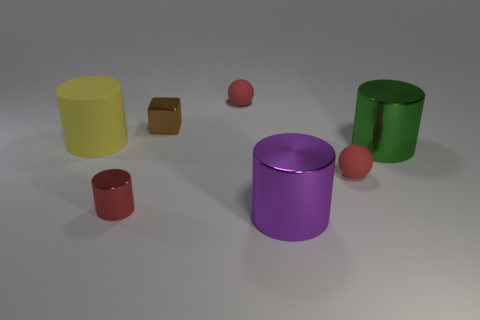Is the shape of the large metallic object that is behind the red shiny cylinder the same as  the tiny red shiny thing?
Your response must be concise. Yes. Is the number of rubber things that are in front of the rubber cylinder greater than the number of big gray rubber things?
Keep it short and to the point. Yes. The other metal thing that is the same size as the brown object is what color?
Give a very brief answer. Red. What number of objects are big cylinders that are in front of the yellow thing or spheres?
Your response must be concise. 4. What is the material of the large cylinder in front of the metal thing on the left side of the tiny brown thing?
Ensure brevity in your answer.  Metal. Are there any red things made of the same material as the yellow cylinder?
Your answer should be compact. Yes. Are there any purple cylinders behind the rubber object in front of the matte cylinder?
Your response must be concise. No. There is a purple cylinder right of the red shiny cylinder; what material is it?
Make the answer very short. Metal. Does the purple metal thing have the same shape as the big yellow rubber thing?
Your answer should be compact. Yes. What color is the big thing on the left side of the tiny red matte ball left of the large cylinder that is in front of the large green object?
Make the answer very short. Yellow. 